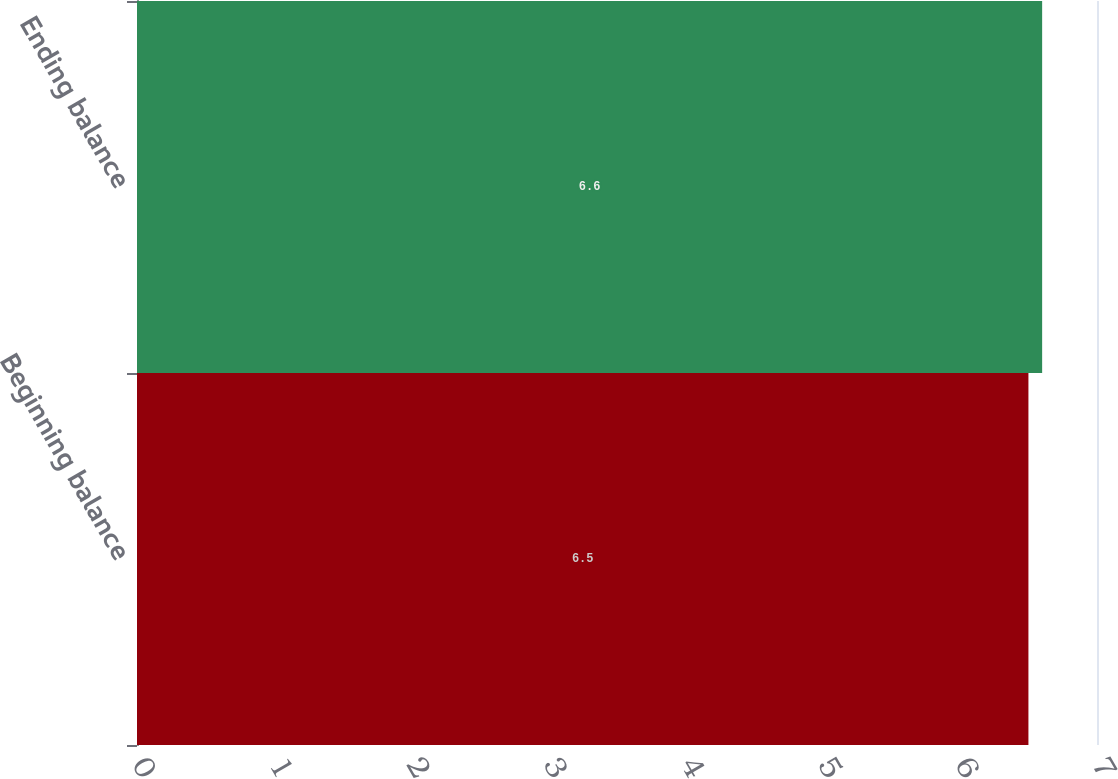<chart> <loc_0><loc_0><loc_500><loc_500><bar_chart><fcel>Beginning balance<fcel>Ending balance<nl><fcel>6.5<fcel>6.6<nl></chart> 